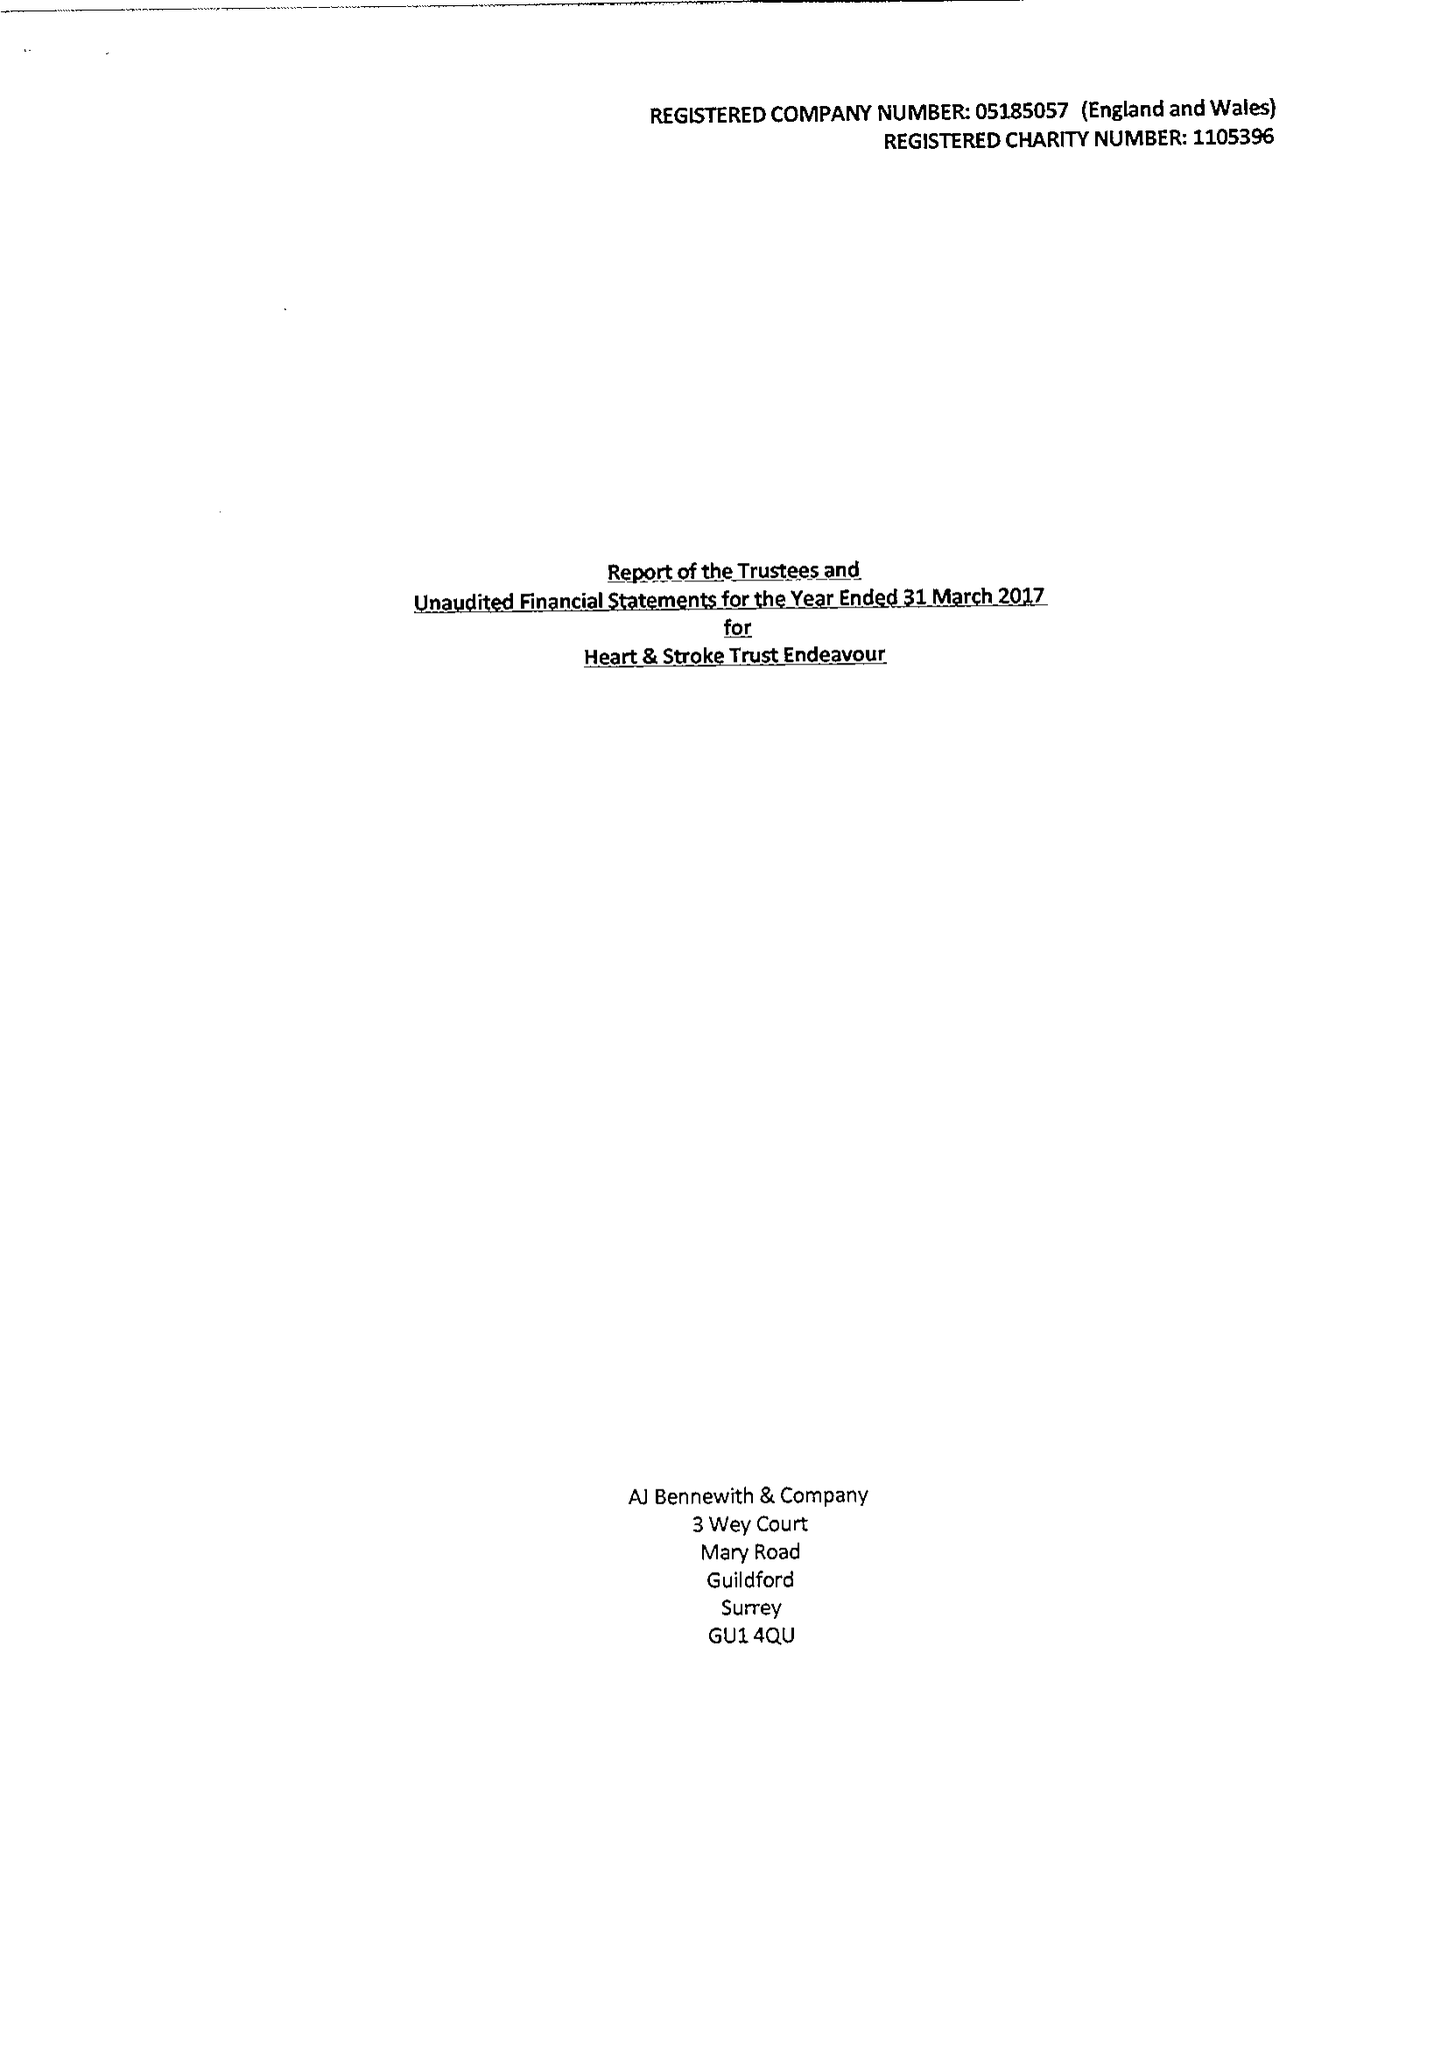What is the value for the spending_annually_in_british_pounds?
Answer the question using a single word or phrase. 2388.00 